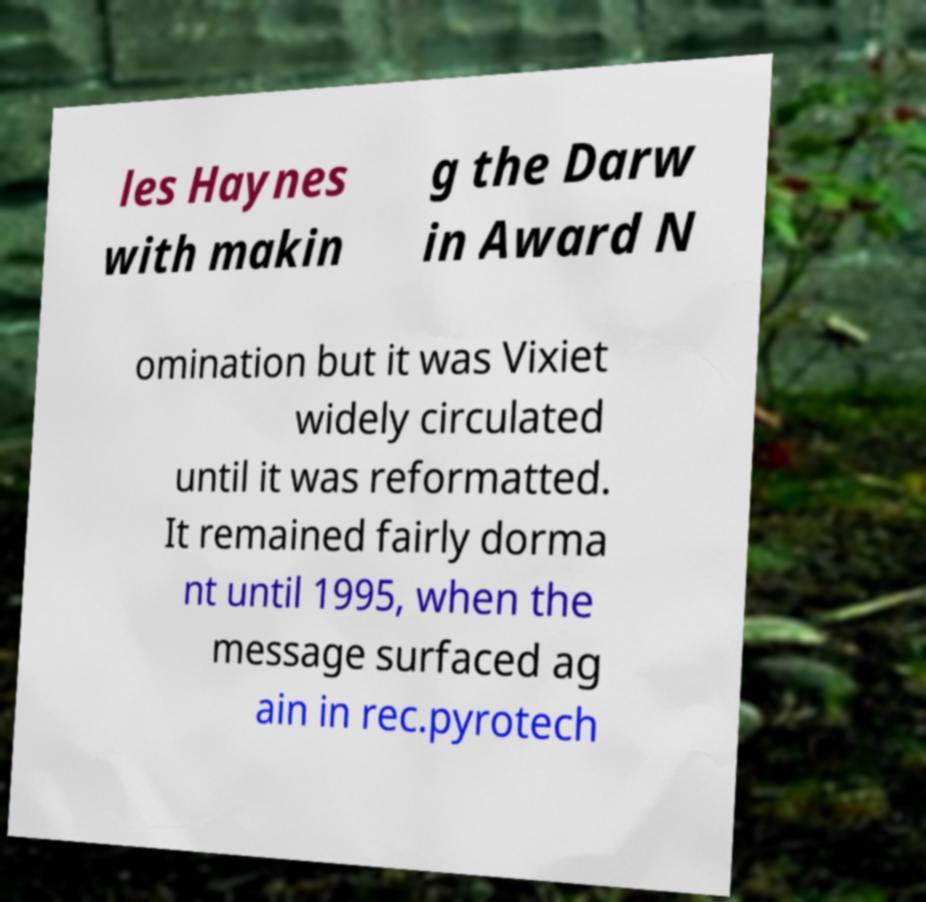Please read and relay the text visible in this image. What does it say? les Haynes with makin g the Darw in Award N omination but it was Vixiet widely circulated until it was reformatted. It remained fairly dorma nt until 1995, when the message surfaced ag ain in rec.pyrotech 